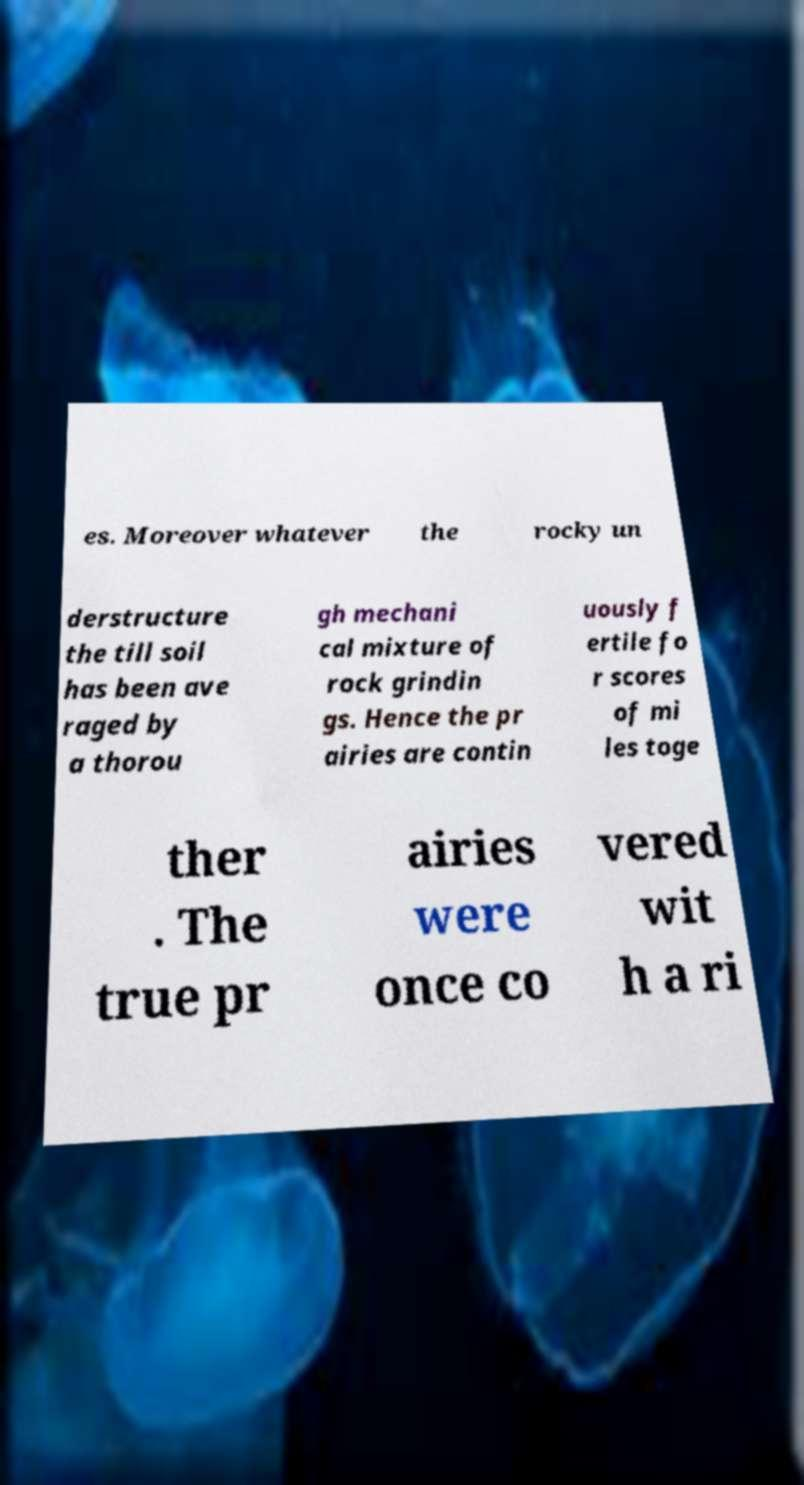Could you extract and type out the text from this image? es. Moreover whatever the rocky un derstructure the till soil has been ave raged by a thorou gh mechani cal mixture of rock grindin gs. Hence the pr airies are contin uously f ertile fo r scores of mi les toge ther . The true pr airies were once co vered wit h a ri 